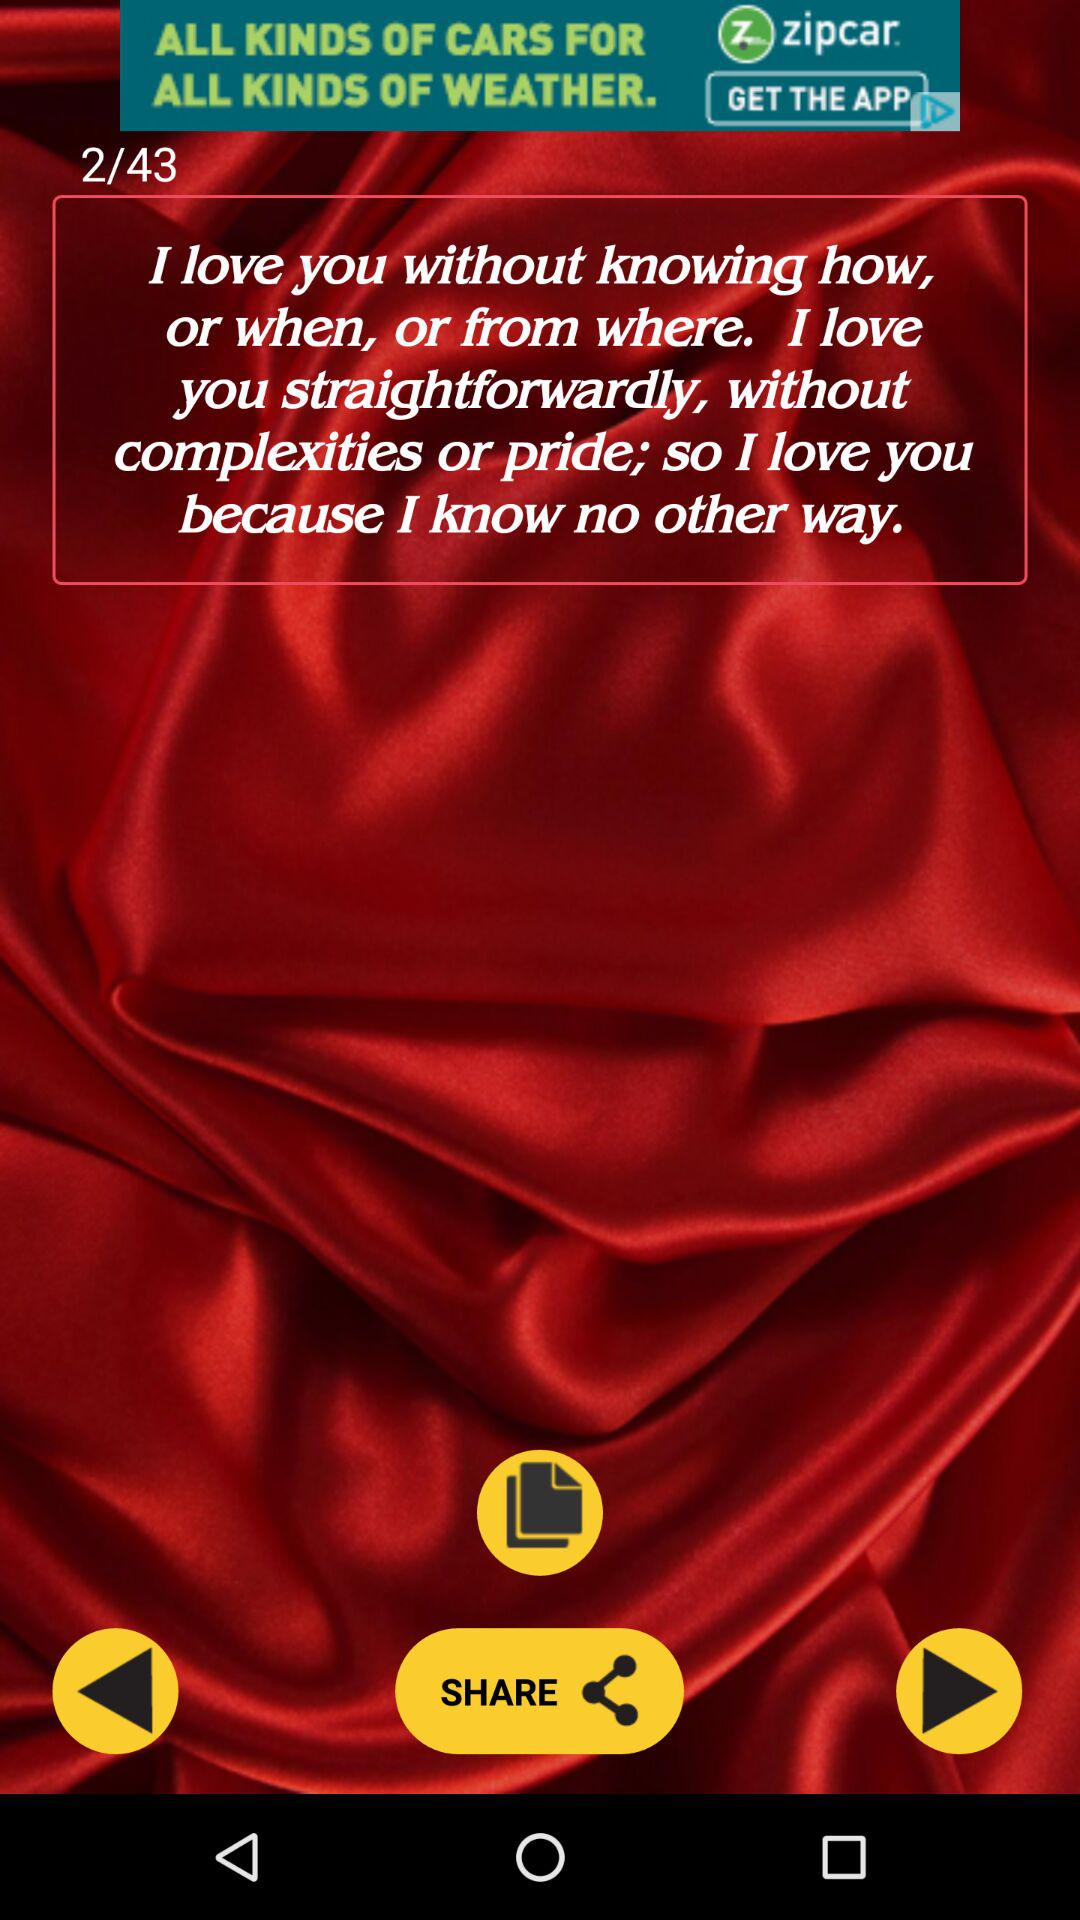How many total images are there? There are 43 total images. 